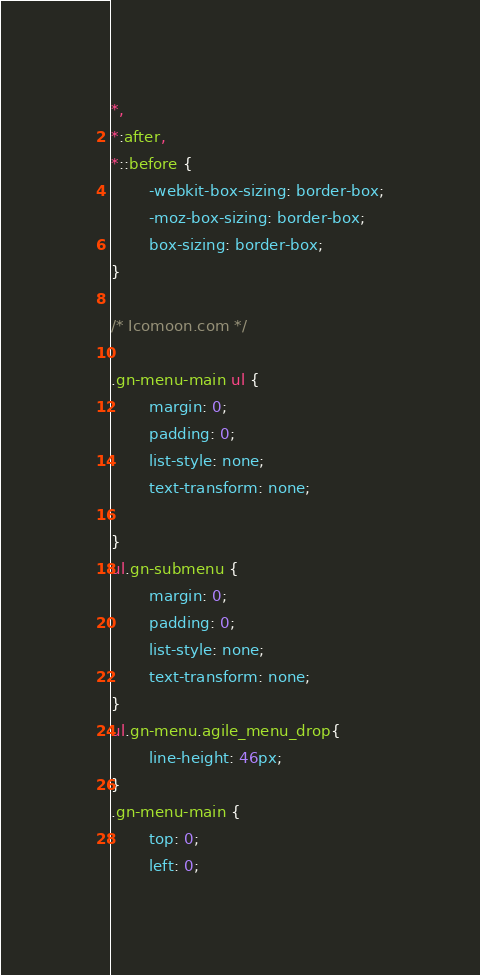Convert code to text. <code><loc_0><loc_0><loc_500><loc_500><_CSS_>*,
*:after,
*::before {
		-webkit-box-sizing: border-box;
		-moz-box-sizing: border-box;
		box-sizing: border-box;
}

/* Icomoon.com */

.gn-menu-main ul {
		margin: 0;
		padding: 0;
		list-style: none;
		text-transform: none;

}
ul.gn-submenu {
		margin: 0;
		padding: 0;
		list-style: none;
		text-transform: none;
}
ul.gn-menu.agile_menu_drop{
	    line-height: 46px;
}
.gn-menu-main {
		top: 0;
		left: 0;</code> 